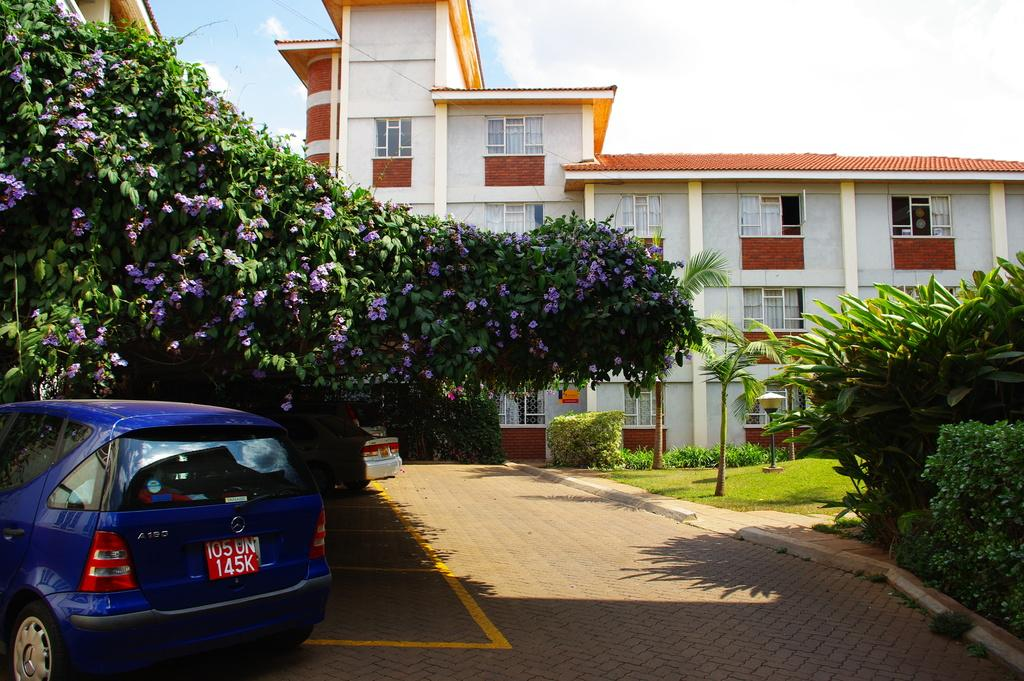What type of vehicles can be seen in the image? There are cars in the image. What other elements are present in the image besides cars? There are plants, flowers, buildings, trees, and clouds in the image. Can you describe the plants and flowers in the image? The plants and flowers are not specified, but they are present in the image. What can be seen in the background of the image? In the background of the image, there are buildings, trees, and clouds. What type of calculator is the daughter using in the image? There is no daughter or calculator present in the image. 